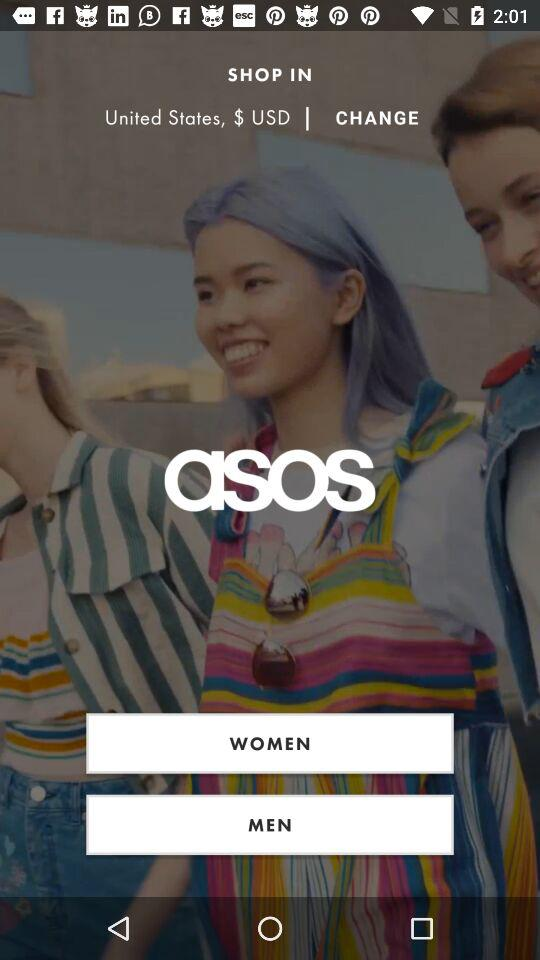Which gender is selected?
When the provided information is insufficient, respond with <no answer>. <no answer> 